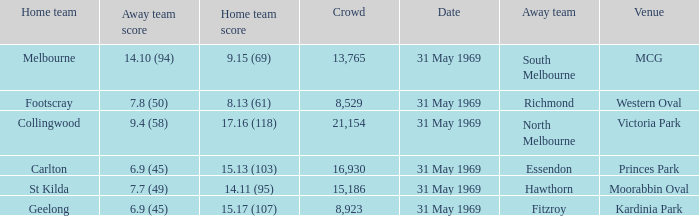Who was the home team in the game where North Melbourne was the away team? 17.16 (118). 